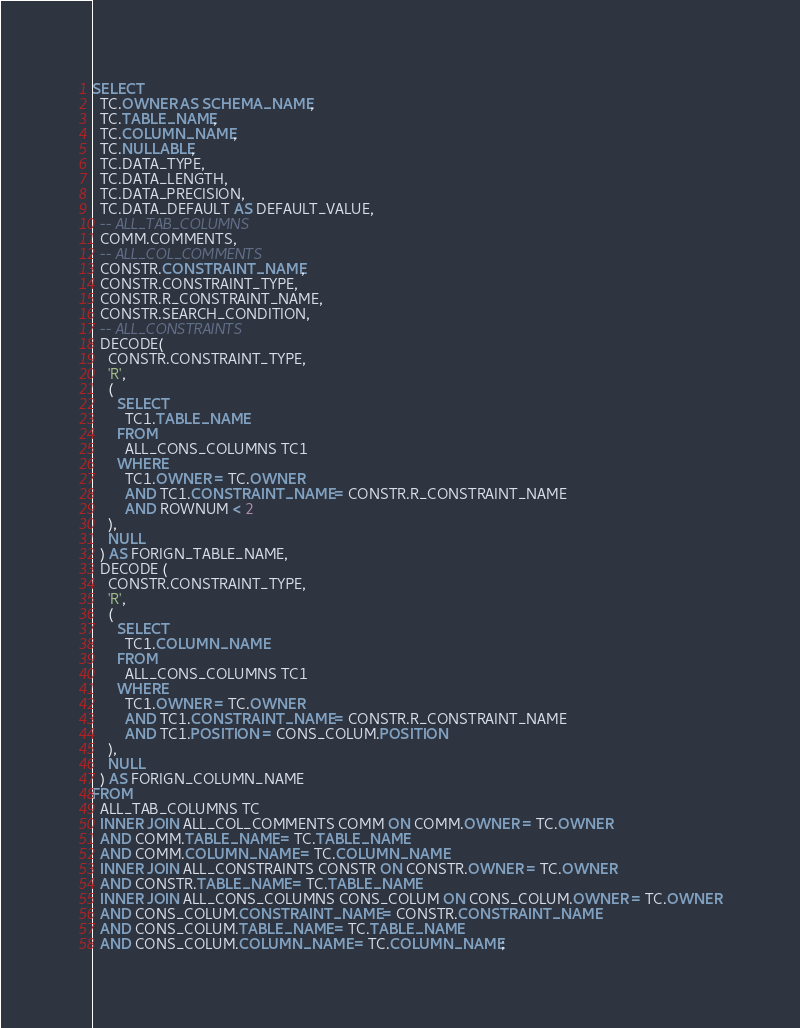<code> <loc_0><loc_0><loc_500><loc_500><_SQL_>SELECT
  TC.OWNER AS SCHEMA_NAME,
  TC.TABLE_NAME,
  TC.COLUMN_NAME,
  TC.NULLABLE,
  TC.DATA_TYPE,
  TC.DATA_LENGTH,
  TC.DATA_PRECISION,
  TC.DATA_DEFAULT AS DEFAULT_VALUE,
  -- ALL_TAB_COLUMNS
  COMM.COMMENTS,
  -- ALL_COL_COMMENTS
  CONSTR.CONSTRAINT_NAME,
  CONSTR.CONSTRAINT_TYPE,
  CONSTR.R_CONSTRAINT_NAME,
  CONSTR.SEARCH_CONDITION,
  -- ALL_CONSTRAINTS
  DECODE(
    CONSTR.CONSTRAINT_TYPE,
    'R',
    (
      SELECT
        TC1.TABLE_NAME
      FROM
        ALL_CONS_COLUMNS TC1
      WHERE
        TC1.OWNER = TC.OWNER
        AND TC1.CONSTRAINT_NAME = CONSTR.R_CONSTRAINT_NAME
        AND ROWNUM < 2
    ),
    NULL
  ) AS FORIGN_TABLE_NAME,
  DECODE (
  	CONSTR.CONSTRAINT_TYPE,
    'R', 
    (
      SELECT
        TC1.COLUMN_NAME
      FROM
        ALL_CONS_COLUMNS TC1
      WHERE
        TC1.OWNER = TC.OWNER
        AND TC1.CONSTRAINT_NAME = CONSTR.R_CONSTRAINT_NAME
        AND TC1.POSITION = CONS_COLUM.POSITION
    ),
    NULL
  ) AS FORIGN_COLUMN_NAME
FROM
  ALL_TAB_COLUMNS TC
  INNER JOIN ALL_COL_COMMENTS COMM ON COMM.OWNER = TC.OWNER
  AND COMM.TABLE_NAME = TC.TABLE_NAME
  AND COMM.COLUMN_NAME = TC.COLUMN_NAME
  INNER JOIN ALL_CONSTRAINTS CONSTR ON CONSTR.OWNER = TC.OWNER
  AND CONSTR.TABLE_NAME = TC.TABLE_NAME
  INNER JOIN ALL_CONS_COLUMNS CONS_COLUM ON CONS_COLUM.OWNER = TC.OWNER
  AND CONS_COLUM.CONSTRAINT_NAME = CONSTR.CONSTRAINT_NAME
  AND CONS_COLUM.TABLE_NAME = TC.TABLE_NAME
  AND CONS_COLUM.COLUMN_NAME = TC.COLUMN_NAME;</code> 